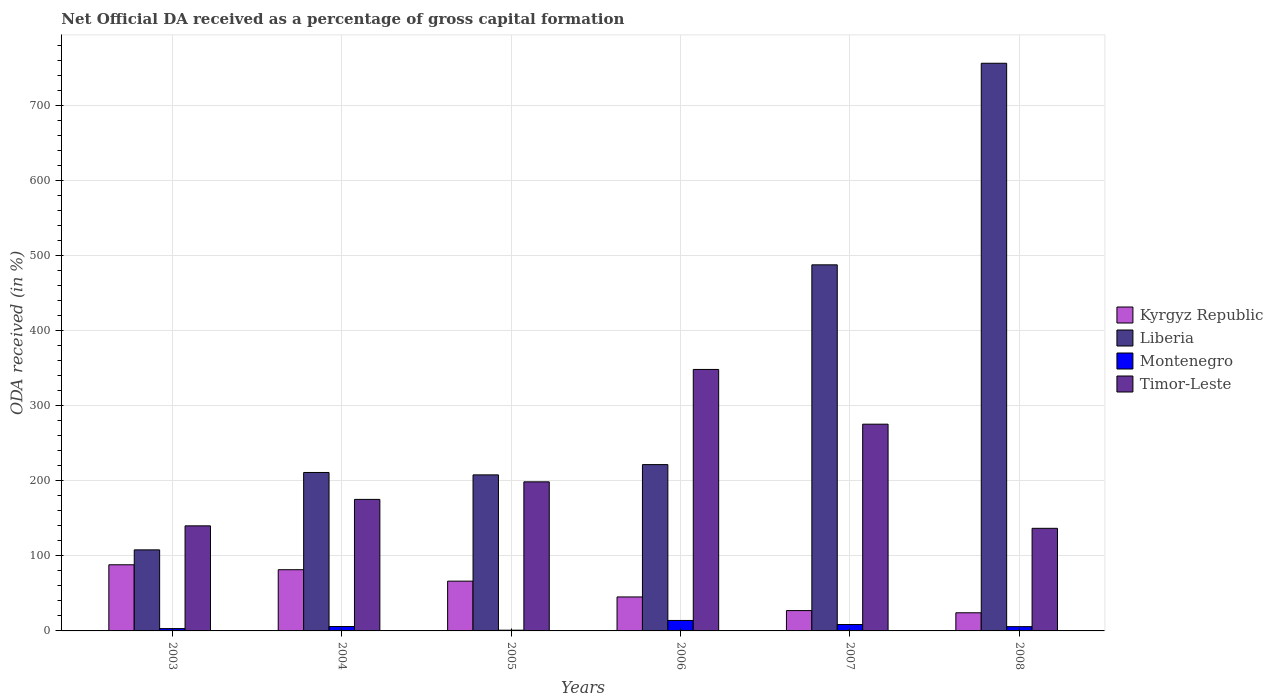How many different coloured bars are there?
Provide a succinct answer. 4. How many groups of bars are there?
Your answer should be compact. 6. Are the number of bars per tick equal to the number of legend labels?
Give a very brief answer. Yes. Are the number of bars on each tick of the X-axis equal?
Your answer should be compact. Yes. How many bars are there on the 4th tick from the left?
Keep it short and to the point. 4. How many bars are there on the 2nd tick from the right?
Your answer should be very brief. 4. In how many cases, is the number of bars for a given year not equal to the number of legend labels?
Provide a short and direct response. 0. What is the net ODA received in Timor-Leste in 2008?
Provide a succinct answer. 136.72. Across all years, what is the maximum net ODA received in Montenegro?
Keep it short and to the point. 13.93. Across all years, what is the minimum net ODA received in Timor-Leste?
Ensure brevity in your answer.  136.72. What is the total net ODA received in Montenegro in the graph?
Offer a terse response. 38.05. What is the difference between the net ODA received in Montenegro in 2004 and that in 2007?
Ensure brevity in your answer.  -2.68. What is the difference between the net ODA received in Timor-Leste in 2007 and the net ODA received in Montenegro in 2004?
Your answer should be very brief. 269.68. What is the average net ODA received in Timor-Leste per year?
Provide a short and direct response. 212.44. In the year 2008, what is the difference between the net ODA received in Montenegro and net ODA received in Liberia?
Offer a very short reply. -750.77. In how many years, is the net ODA received in Montenegro greater than 680 %?
Ensure brevity in your answer.  0. What is the ratio of the net ODA received in Timor-Leste in 2003 to that in 2005?
Your answer should be compact. 0.7. Is the difference between the net ODA received in Montenegro in 2003 and 2008 greater than the difference between the net ODA received in Liberia in 2003 and 2008?
Provide a short and direct response. Yes. What is the difference between the highest and the second highest net ODA received in Liberia?
Give a very brief answer. 268.63. What is the difference between the highest and the lowest net ODA received in Kyrgyz Republic?
Offer a very short reply. 63.95. In how many years, is the net ODA received in Kyrgyz Republic greater than the average net ODA received in Kyrgyz Republic taken over all years?
Your response must be concise. 3. Is it the case that in every year, the sum of the net ODA received in Liberia and net ODA received in Timor-Leste is greater than the sum of net ODA received in Kyrgyz Republic and net ODA received in Montenegro?
Ensure brevity in your answer.  No. What does the 1st bar from the left in 2008 represents?
Give a very brief answer. Kyrgyz Republic. What does the 1st bar from the right in 2007 represents?
Provide a short and direct response. Timor-Leste. Are all the bars in the graph horizontal?
Provide a succinct answer. No. How many years are there in the graph?
Ensure brevity in your answer.  6. What is the difference between two consecutive major ticks on the Y-axis?
Give a very brief answer. 100. Are the values on the major ticks of Y-axis written in scientific E-notation?
Your response must be concise. No. Does the graph contain any zero values?
Ensure brevity in your answer.  No. Does the graph contain grids?
Offer a very short reply. Yes. How are the legend labels stacked?
Your response must be concise. Vertical. What is the title of the graph?
Provide a short and direct response. Net Official DA received as a percentage of gross capital formation. Does "San Marino" appear as one of the legend labels in the graph?
Your answer should be compact. No. What is the label or title of the X-axis?
Keep it short and to the point. Years. What is the label or title of the Y-axis?
Ensure brevity in your answer.  ODA received (in %). What is the ODA received (in %) in Kyrgyz Republic in 2003?
Keep it short and to the point. 88.14. What is the ODA received (in %) of Liberia in 2003?
Offer a very short reply. 108.02. What is the ODA received (in %) in Montenegro in 2003?
Make the answer very short. 3.09. What is the ODA received (in %) in Timor-Leste in 2003?
Your response must be concise. 140.02. What is the ODA received (in %) in Kyrgyz Republic in 2004?
Ensure brevity in your answer.  81.57. What is the ODA received (in %) in Liberia in 2004?
Offer a terse response. 211.14. What is the ODA received (in %) in Montenegro in 2004?
Provide a short and direct response. 5.84. What is the ODA received (in %) in Timor-Leste in 2004?
Keep it short and to the point. 175.26. What is the ODA received (in %) in Kyrgyz Republic in 2005?
Offer a very short reply. 66.32. What is the ODA received (in %) in Liberia in 2005?
Give a very brief answer. 207.93. What is the ODA received (in %) in Montenegro in 2005?
Your response must be concise. 0.96. What is the ODA received (in %) in Timor-Leste in 2005?
Keep it short and to the point. 198.67. What is the ODA received (in %) in Kyrgyz Republic in 2006?
Offer a very short reply. 45.29. What is the ODA received (in %) in Liberia in 2006?
Your response must be concise. 221.64. What is the ODA received (in %) in Montenegro in 2006?
Your answer should be very brief. 13.93. What is the ODA received (in %) in Timor-Leste in 2006?
Make the answer very short. 348.45. What is the ODA received (in %) in Kyrgyz Republic in 2007?
Your response must be concise. 27.09. What is the ODA received (in %) of Liberia in 2007?
Ensure brevity in your answer.  487.84. What is the ODA received (in %) of Montenegro in 2007?
Ensure brevity in your answer.  8.52. What is the ODA received (in %) of Timor-Leste in 2007?
Your answer should be very brief. 275.51. What is the ODA received (in %) of Kyrgyz Republic in 2008?
Offer a terse response. 24.19. What is the ODA received (in %) in Liberia in 2008?
Your answer should be very brief. 756.47. What is the ODA received (in %) of Montenegro in 2008?
Provide a short and direct response. 5.7. What is the ODA received (in %) in Timor-Leste in 2008?
Give a very brief answer. 136.72. Across all years, what is the maximum ODA received (in %) of Kyrgyz Republic?
Your answer should be compact. 88.14. Across all years, what is the maximum ODA received (in %) of Liberia?
Offer a terse response. 756.47. Across all years, what is the maximum ODA received (in %) in Montenegro?
Ensure brevity in your answer.  13.93. Across all years, what is the maximum ODA received (in %) of Timor-Leste?
Provide a short and direct response. 348.45. Across all years, what is the minimum ODA received (in %) in Kyrgyz Republic?
Give a very brief answer. 24.19. Across all years, what is the minimum ODA received (in %) in Liberia?
Make the answer very short. 108.02. Across all years, what is the minimum ODA received (in %) of Montenegro?
Offer a very short reply. 0.96. Across all years, what is the minimum ODA received (in %) in Timor-Leste?
Provide a succinct answer. 136.72. What is the total ODA received (in %) in Kyrgyz Republic in the graph?
Offer a very short reply. 332.6. What is the total ODA received (in %) of Liberia in the graph?
Offer a very short reply. 1993.05. What is the total ODA received (in %) in Montenegro in the graph?
Keep it short and to the point. 38.05. What is the total ODA received (in %) of Timor-Leste in the graph?
Your answer should be very brief. 1274.64. What is the difference between the ODA received (in %) in Kyrgyz Republic in 2003 and that in 2004?
Your answer should be compact. 6.57. What is the difference between the ODA received (in %) of Liberia in 2003 and that in 2004?
Your response must be concise. -103.12. What is the difference between the ODA received (in %) of Montenegro in 2003 and that in 2004?
Provide a succinct answer. -2.75. What is the difference between the ODA received (in %) in Timor-Leste in 2003 and that in 2004?
Give a very brief answer. -35.24. What is the difference between the ODA received (in %) of Kyrgyz Republic in 2003 and that in 2005?
Offer a very short reply. 21.82. What is the difference between the ODA received (in %) of Liberia in 2003 and that in 2005?
Your response must be concise. -99.91. What is the difference between the ODA received (in %) in Montenegro in 2003 and that in 2005?
Your response must be concise. 2.13. What is the difference between the ODA received (in %) of Timor-Leste in 2003 and that in 2005?
Provide a succinct answer. -58.64. What is the difference between the ODA received (in %) of Kyrgyz Republic in 2003 and that in 2006?
Keep it short and to the point. 42.86. What is the difference between the ODA received (in %) in Liberia in 2003 and that in 2006?
Offer a very short reply. -113.62. What is the difference between the ODA received (in %) in Montenegro in 2003 and that in 2006?
Provide a succinct answer. -10.84. What is the difference between the ODA received (in %) in Timor-Leste in 2003 and that in 2006?
Your answer should be compact. -208.43. What is the difference between the ODA received (in %) in Kyrgyz Republic in 2003 and that in 2007?
Offer a very short reply. 61.05. What is the difference between the ODA received (in %) in Liberia in 2003 and that in 2007?
Your response must be concise. -379.82. What is the difference between the ODA received (in %) of Montenegro in 2003 and that in 2007?
Give a very brief answer. -5.43. What is the difference between the ODA received (in %) in Timor-Leste in 2003 and that in 2007?
Your answer should be compact. -135.49. What is the difference between the ODA received (in %) of Kyrgyz Republic in 2003 and that in 2008?
Provide a succinct answer. 63.95. What is the difference between the ODA received (in %) of Liberia in 2003 and that in 2008?
Keep it short and to the point. -648.45. What is the difference between the ODA received (in %) in Montenegro in 2003 and that in 2008?
Your response must be concise. -2.61. What is the difference between the ODA received (in %) of Timor-Leste in 2003 and that in 2008?
Provide a succinct answer. 3.3. What is the difference between the ODA received (in %) of Kyrgyz Republic in 2004 and that in 2005?
Keep it short and to the point. 15.25. What is the difference between the ODA received (in %) in Liberia in 2004 and that in 2005?
Give a very brief answer. 3.2. What is the difference between the ODA received (in %) in Montenegro in 2004 and that in 2005?
Make the answer very short. 4.87. What is the difference between the ODA received (in %) of Timor-Leste in 2004 and that in 2005?
Ensure brevity in your answer.  -23.41. What is the difference between the ODA received (in %) of Kyrgyz Republic in 2004 and that in 2006?
Provide a short and direct response. 36.29. What is the difference between the ODA received (in %) of Liberia in 2004 and that in 2006?
Your answer should be very brief. -10.5. What is the difference between the ODA received (in %) in Montenegro in 2004 and that in 2006?
Ensure brevity in your answer.  -8.1. What is the difference between the ODA received (in %) of Timor-Leste in 2004 and that in 2006?
Make the answer very short. -173.19. What is the difference between the ODA received (in %) of Kyrgyz Republic in 2004 and that in 2007?
Make the answer very short. 54.48. What is the difference between the ODA received (in %) of Liberia in 2004 and that in 2007?
Your response must be concise. -276.7. What is the difference between the ODA received (in %) of Montenegro in 2004 and that in 2007?
Offer a terse response. -2.68. What is the difference between the ODA received (in %) in Timor-Leste in 2004 and that in 2007?
Offer a terse response. -100.25. What is the difference between the ODA received (in %) in Kyrgyz Republic in 2004 and that in 2008?
Offer a terse response. 57.38. What is the difference between the ODA received (in %) of Liberia in 2004 and that in 2008?
Ensure brevity in your answer.  -545.33. What is the difference between the ODA received (in %) of Montenegro in 2004 and that in 2008?
Your response must be concise. 0.13. What is the difference between the ODA received (in %) of Timor-Leste in 2004 and that in 2008?
Your answer should be very brief. 38.54. What is the difference between the ODA received (in %) in Kyrgyz Republic in 2005 and that in 2006?
Offer a terse response. 21.03. What is the difference between the ODA received (in %) in Liberia in 2005 and that in 2006?
Make the answer very short. -13.7. What is the difference between the ODA received (in %) in Montenegro in 2005 and that in 2006?
Your answer should be very brief. -12.97. What is the difference between the ODA received (in %) of Timor-Leste in 2005 and that in 2006?
Ensure brevity in your answer.  -149.78. What is the difference between the ODA received (in %) of Kyrgyz Republic in 2005 and that in 2007?
Offer a terse response. 39.23. What is the difference between the ODA received (in %) of Liberia in 2005 and that in 2007?
Your response must be concise. -279.91. What is the difference between the ODA received (in %) of Montenegro in 2005 and that in 2007?
Offer a terse response. -7.55. What is the difference between the ODA received (in %) in Timor-Leste in 2005 and that in 2007?
Your answer should be compact. -76.85. What is the difference between the ODA received (in %) of Kyrgyz Republic in 2005 and that in 2008?
Offer a very short reply. 42.13. What is the difference between the ODA received (in %) in Liberia in 2005 and that in 2008?
Provide a succinct answer. -548.54. What is the difference between the ODA received (in %) of Montenegro in 2005 and that in 2008?
Offer a very short reply. -4.74. What is the difference between the ODA received (in %) in Timor-Leste in 2005 and that in 2008?
Offer a terse response. 61.95. What is the difference between the ODA received (in %) of Kyrgyz Republic in 2006 and that in 2007?
Keep it short and to the point. 18.2. What is the difference between the ODA received (in %) of Liberia in 2006 and that in 2007?
Your answer should be very brief. -266.2. What is the difference between the ODA received (in %) in Montenegro in 2006 and that in 2007?
Your answer should be compact. 5.42. What is the difference between the ODA received (in %) in Timor-Leste in 2006 and that in 2007?
Provide a succinct answer. 72.94. What is the difference between the ODA received (in %) in Kyrgyz Republic in 2006 and that in 2008?
Offer a very short reply. 21.1. What is the difference between the ODA received (in %) in Liberia in 2006 and that in 2008?
Provide a succinct answer. -534.83. What is the difference between the ODA received (in %) in Montenegro in 2006 and that in 2008?
Keep it short and to the point. 8.23. What is the difference between the ODA received (in %) of Timor-Leste in 2006 and that in 2008?
Your answer should be very brief. 211.73. What is the difference between the ODA received (in %) of Kyrgyz Republic in 2007 and that in 2008?
Your answer should be compact. 2.9. What is the difference between the ODA received (in %) in Liberia in 2007 and that in 2008?
Give a very brief answer. -268.63. What is the difference between the ODA received (in %) in Montenegro in 2007 and that in 2008?
Offer a very short reply. 2.81. What is the difference between the ODA received (in %) in Timor-Leste in 2007 and that in 2008?
Make the answer very short. 138.8. What is the difference between the ODA received (in %) of Kyrgyz Republic in 2003 and the ODA received (in %) of Liberia in 2004?
Your answer should be very brief. -123. What is the difference between the ODA received (in %) of Kyrgyz Republic in 2003 and the ODA received (in %) of Montenegro in 2004?
Your answer should be compact. 82.3. What is the difference between the ODA received (in %) of Kyrgyz Republic in 2003 and the ODA received (in %) of Timor-Leste in 2004?
Ensure brevity in your answer.  -87.12. What is the difference between the ODA received (in %) in Liberia in 2003 and the ODA received (in %) in Montenegro in 2004?
Make the answer very short. 102.18. What is the difference between the ODA received (in %) in Liberia in 2003 and the ODA received (in %) in Timor-Leste in 2004?
Offer a very short reply. -67.24. What is the difference between the ODA received (in %) in Montenegro in 2003 and the ODA received (in %) in Timor-Leste in 2004?
Offer a terse response. -172.17. What is the difference between the ODA received (in %) in Kyrgyz Republic in 2003 and the ODA received (in %) in Liberia in 2005?
Your answer should be compact. -119.79. What is the difference between the ODA received (in %) of Kyrgyz Republic in 2003 and the ODA received (in %) of Montenegro in 2005?
Keep it short and to the point. 87.18. What is the difference between the ODA received (in %) in Kyrgyz Republic in 2003 and the ODA received (in %) in Timor-Leste in 2005?
Your answer should be compact. -110.52. What is the difference between the ODA received (in %) in Liberia in 2003 and the ODA received (in %) in Montenegro in 2005?
Make the answer very short. 107.06. What is the difference between the ODA received (in %) of Liberia in 2003 and the ODA received (in %) of Timor-Leste in 2005?
Provide a short and direct response. -90.65. What is the difference between the ODA received (in %) in Montenegro in 2003 and the ODA received (in %) in Timor-Leste in 2005?
Offer a very short reply. -195.57. What is the difference between the ODA received (in %) of Kyrgyz Republic in 2003 and the ODA received (in %) of Liberia in 2006?
Provide a succinct answer. -133.5. What is the difference between the ODA received (in %) in Kyrgyz Republic in 2003 and the ODA received (in %) in Montenegro in 2006?
Your answer should be very brief. 74.21. What is the difference between the ODA received (in %) in Kyrgyz Republic in 2003 and the ODA received (in %) in Timor-Leste in 2006?
Provide a succinct answer. -260.31. What is the difference between the ODA received (in %) in Liberia in 2003 and the ODA received (in %) in Montenegro in 2006?
Offer a very short reply. 94.09. What is the difference between the ODA received (in %) in Liberia in 2003 and the ODA received (in %) in Timor-Leste in 2006?
Ensure brevity in your answer.  -240.43. What is the difference between the ODA received (in %) of Montenegro in 2003 and the ODA received (in %) of Timor-Leste in 2006?
Offer a terse response. -345.36. What is the difference between the ODA received (in %) of Kyrgyz Republic in 2003 and the ODA received (in %) of Liberia in 2007?
Your answer should be compact. -399.7. What is the difference between the ODA received (in %) in Kyrgyz Republic in 2003 and the ODA received (in %) in Montenegro in 2007?
Offer a terse response. 79.62. What is the difference between the ODA received (in %) of Kyrgyz Republic in 2003 and the ODA received (in %) of Timor-Leste in 2007?
Make the answer very short. -187.37. What is the difference between the ODA received (in %) in Liberia in 2003 and the ODA received (in %) in Montenegro in 2007?
Your answer should be very brief. 99.5. What is the difference between the ODA received (in %) in Liberia in 2003 and the ODA received (in %) in Timor-Leste in 2007?
Keep it short and to the point. -167.49. What is the difference between the ODA received (in %) of Montenegro in 2003 and the ODA received (in %) of Timor-Leste in 2007?
Ensure brevity in your answer.  -272.42. What is the difference between the ODA received (in %) of Kyrgyz Republic in 2003 and the ODA received (in %) of Liberia in 2008?
Give a very brief answer. -668.33. What is the difference between the ODA received (in %) of Kyrgyz Republic in 2003 and the ODA received (in %) of Montenegro in 2008?
Your answer should be compact. 82.44. What is the difference between the ODA received (in %) in Kyrgyz Republic in 2003 and the ODA received (in %) in Timor-Leste in 2008?
Your answer should be very brief. -48.58. What is the difference between the ODA received (in %) of Liberia in 2003 and the ODA received (in %) of Montenegro in 2008?
Your response must be concise. 102.32. What is the difference between the ODA received (in %) in Liberia in 2003 and the ODA received (in %) in Timor-Leste in 2008?
Ensure brevity in your answer.  -28.7. What is the difference between the ODA received (in %) in Montenegro in 2003 and the ODA received (in %) in Timor-Leste in 2008?
Your answer should be compact. -133.63. What is the difference between the ODA received (in %) of Kyrgyz Republic in 2004 and the ODA received (in %) of Liberia in 2005?
Provide a short and direct response. -126.36. What is the difference between the ODA received (in %) in Kyrgyz Republic in 2004 and the ODA received (in %) in Montenegro in 2005?
Give a very brief answer. 80.61. What is the difference between the ODA received (in %) of Kyrgyz Republic in 2004 and the ODA received (in %) of Timor-Leste in 2005?
Keep it short and to the point. -117.09. What is the difference between the ODA received (in %) of Liberia in 2004 and the ODA received (in %) of Montenegro in 2005?
Offer a terse response. 210.17. What is the difference between the ODA received (in %) of Liberia in 2004 and the ODA received (in %) of Timor-Leste in 2005?
Provide a short and direct response. 12.47. What is the difference between the ODA received (in %) of Montenegro in 2004 and the ODA received (in %) of Timor-Leste in 2005?
Provide a succinct answer. -192.83. What is the difference between the ODA received (in %) in Kyrgyz Republic in 2004 and the ODA received (in %) in Liberia in 2006?
Provide a succinct answer. -140.07. What is the difference between the ODA received (in %) of Kyrgyz Republic in 2004 and the ODA received (in %) of Montenegro in 2006?
Your answer should be compact. 67.64. What is the difference between the ODA received (in %) in Kyrgyz Republic in 2004 and the ODA received (in %) in Timor-Leste in 2006?
Ensure brevity in your answer.  -266.88. What is the difference between the ODA received (in %) of Liberia in 2004 and the ODA received (in %) of Montenegro in 2006?
Provide a succinct answer. 197.2. What is the difference between the ODA received (in %) of Liberia in 2004 and the ODA received (in %) of Timor-Leste in 2006?
Make the answer very short. -137.31. What is the difference between the ODA received (in %) in Montenegro in 2004 and the ODA received (in %) in Timor-Leste in 2006?
Your answer should be compact. -342.61. What is the difference between the ODA received (in %) in Kyrgyz Republic in 2004 and the ODA received (in %) in Liberia in 2007?
Keep it short and to the point. -406.27. What is the difference between the ODA received (in %) in Kyrgyz Republic in 2004 and the ODA received (in %) in Montenegro in 2007?
Make the answer very short. 73.05. What is the difference between the ODA received (in %) in Kyrgyz Republic in 2004 and the ODA received (in %) in Timor-Leste in 2007?
Provide a short and direct response. -193.94. What is the difference between the ODA received (in %) of Liberia in 2004 and the ODA received (in %) of Montenegro in 2007?
Provide a succinct answer. 202.62. What is the difference between the ODA received (in %) of Liberia in 2004 and the ODA received (in %) of Timor-Leste in 2007?
Your answer should be compact. -64.38. What is the difference between the ODA received (in %) in Montenegro in 2004 and the ODA received (in %) in Timor-Leste in 2007?
Ensure brevity in your answer.  -269.68. What is the difference between the ODA received (in %) of Kyrgyz Republic in 2004 and the ODA received (in %) of Liberia in 2008?
Ensure brevity in your answer.  -674.9. What is the difference between the ODA received (in %) of Kyrgyz Republic in 2004 and the ODA received (in %) of Montenegro in 2008?
Give a very brief answer. 75.87. What is the difference between the ODA received (in %) in Kyrgyz Republic in 2004 and the ODA received (in %) in Timor-Leste in 2008?
Your answer should be compact. -55.15. What is the difference between the ODA received (in %) of Liberia in 2004 and the ODA received (in %) of Montenegro in 2008?
Keep it short and to the point. 205.43. What is the difference between the ODA received (in %) of Liberia in 2004 and the ODA received (in %) of Timor-Leste in 2008?
Your response must be concise. 74.42. What is the difference between the ODA received (in %) in Montenegro in 2004 and the ODA received (in %) in Timor-Leste in 2008?
Ensure brevity in your answer.  -130.88. What is the difference between the ODA received (in %) of Kyrgyz Republic in 2005 and the ODA received (in %) of Liberia in 2006?
Make the answer very short. -155.32. What is the difference between the ODA received (in %) in Kyrgyz Republic in 2005 and the ODA received (in %) in Montenegro in 2006?
Provide a short and direct response. 52.38. What is the difference between the ODA received (in %) of Kyrgyz Republic in 2005 and the ODA received (in %) of Timor-Leste in 2006?
Make the answer very short. -282.13. What is the difference between the ODA received (in %) of Liberia in 2005 and the ODA received (in %) of Montenegro in 2006?
Offer a very short reply. 194. What is the difference between the ODA received (in %) in Liberia in 2005 and the ODA received (in %) in Timor-Leste in 2006?
Keep it short and to the point. -140.52. What is the difference between the ODA received (in %) in Montenegro in 2005 and the ODA received (in %) in Timor-Leste in 2006?
Provide a succinct answer. -347.49. What is the difference between the ODA received (in %) of Kyrgyz Republic in 2005 and the ODA received (in %) of Liberia in 2007?
Give a very brief answer. -421.52. What is the difference between the ODA received (in %) of Kyrgyz Republic in 2005 and the ODA received (in %) of Montenegro in 2007?
Provide a succinct answer. 57.8. What is the difference between the ODA received (in %) in Kyrgyz Republic in 2005 and the ODA received (in %) in Timor-Leste in 2007?
Provide a succinct answer. -209.2. What is the difference between the ODA received (in %) in Liberia in 2005 and the ODA received (in %) in Montenegro in 2007?
Offer a very short reply. 199.42. What is the difference between the ODA received (in %) of Liberia in 2005 and the ODA received (in %) of Timor-Leste in 2007?
Give a very brief answer. -67.58. What is the difference between the ODA received (in %) in Montenegro in 2005 and the ODA received (in %) in Timor-Leste in 2007?
Give a very brief answer. -274.55. What is the difference between the ODA received (in %) in Kyrgyz Republic in 2005 and the ODA received (in %) in Liberia in 2008?
Offer a terse response. -690.15. What is the difference between the ODA received (in %) of Kyrgyz Republic in 2005 and the ODA received (in %) of Montenegro in 2008?
Offer a terse response. 60.61. What is the difference between the ODA received (in %) of Kyrgyz Republic in 2005 and the ODA received (in %) of Timor-Leste in 2008?
Keep it short and to the point. -70.4. What is the difference between the ODA received (in %) of Liberia in 2005 and the ODA received (in %) of Montenegro in 2008?
Your response must be concise. 202.23. What is the difference between the ODA received (in %) of Liberia in 2005 and the ODA received (in %) of Timor-Leste in 2008?
Keep it short and to the point. 71.22. What is the difference between the ODA received (in %) in Montenegro in 2005 and the ODA received (in %) in Timor-Leste in 2008?
Your response must be concise. -135.75. What is the difference between the ODA received (in %) of Kyrgyz Republic in 2006 and the ODA received (in %) of Liberia in 2007?
Keep it short and to the point. -442.55. What is the difference between the ODA received (in %) of Kyrgyz Republic in 2006 and the ODA received (in %) of Montenegro in 2007?
Offer a terse response. 36.77. What is the difference between the ODA received (in %) in Kyrgyz Republic in 2006 and the ODA received (in %) in Timor-Leste in 2007?
Provide a succinct answer. -230.23. What is the difference between the ODA received (in %) in Liberia in 2006 and the ODA received (in %) in Montenegro in 2007?
Provide a succinct answer. 213.12. What is the difference between the ODA received (in %) of Liberia in 2006 and the ODA received (in %) of Timor-Leste in 2007?
Your answer should be compact. -53.88. What is the difference between the ODA received (in %) in Montenegro in 2006 and the ODA received (in %) in Timor-Leste in 2007?
Offer a very short reply. -261.58. What is the difference between the ODA received (in %) in Kyrgyz Republic in 2006 and the ODA received (in %) in Liberia in 2008?
Provide a short and direct response. -711.19. What is the difference between the ODA received (in %) in Kyrgyz Republic in 2006 and the ODA received (in %) in Montenegro in 2008?
Provide a succinct answer. 39.58. What is the difference between the ODA received (in %) in Kyrgyz Republic in 2006 and the ODA received (in %) in Timor-Leste in 2008?
Offer a very short reply. -91.43. What is the difference between the ODA received (in %) in Liberia in 2006 and the ODA received (in %) in Montenegro in 2008?
Ensure brevity in your answer.  215.93. What is the difference between the ODA received (in %) of Liberia in 2006 and the ODA received (in %) of Timor-Leste in 2008?
Ensure brevity in your answer.  84.92. What is the difference between the ODA received (in %) in Montenegro in 2006 and the ODA received (in %) in Timor-Leste in 2008?
Provide a succinct answer. -122.78. What is the difference between the ODA received (in %) of Kyrgyz Republic in 2007 and the ODA received (in %) of Liberia in 2008?
Provide a short and direct response. -729.38. What is the difference between the ODA received (in %) of Kyrgyz Republic in 2007 and the ODA received (in %) of Montenegro in 2008?
Give a very brief answer. 21.39. What is the difference between the ODA received (in %) in Kyrgyz Republic in 2007 and the ODA received (in %) in Timor-Leste in 2008?
Make the answer very short. -109.63. What is the difference between the ODA received (in %) in Liberia in 2007 and the ODA received (in %) in Montenegro in 2008?
Your answer should be compact. 482.14. What is the difference between the ODA received (in %) of Liberia in 2007 and the ODA received (in %) of Timor-Leste in 2008?
Offer a terse response. 351.12. What is the difference between the ODA received (in %) of Montenegro in 2007 and the ODA received (in %) of Timor-Leste in 2008?
Provide a succinct answer. -128.2. What is the average ODA received (in %) of Kyrgyz Republic per year?
Keep it short and to the point. 55.43. What is the average ODA received (in %) of Liberia per year?
Your answer should be very brief. 332.17. What is the average ODA received (in %) in Montenegro per year?
Provide a short and direct response. 6.34. What is the average ODA received (in %) of Timor-Leste per year?
Keep it short and to the point. 212.44. In the year 2003, what is the difference between the ODA received (in %) in Kyrgyz Republic and ODA received (in %) in Liberia?
Keep it short and to the point. -19.88. In the year 2003, what is the difference between the ODA received (in %) in Kyrgyz Republic and ODA received (in %) in Montenegro?
Offer a very short reply. 85.05. In the year 2003, what is the difference between the ODA received (in %) in Kyrgyz Republic and ODA received (in %) in Timor-Leste?
Offer a terse response. -51.88. In the year 2003, what is the difference between the ODA received (in %) of Liberia and ODA received (in %) of Montenegro?
Offer a terse response. 104.93. In the year 2003, what is the difference between the ODA received (in %) of Liberia and ODA received (in %) of Timor-Leste?
Offer a very short reply. -32. In the year 2003, what is the difference between the ODA received (in %) of Montenegro and ODA received (in %) of Timor-Leste?
Provide a succinct answer. -136.93. In the year 2004, what is the difference between the ODA received (in %) of Kyrgyz Republic and ODA received (in %) of Liberia?
Give a very brief answer. -129.57. In the year 2004, what is the difference between the ODA received (in %) in Kyrgyz Republic and ODA received (in %) in Montenegro?
Ensure brevity in your answer.  75.73. In the year 2004, what is the difference between the ODA received (in %) of Kyrgyz Republic and ODA received (in %) of Timor-Leste?
Provide a succinct answer. -93.69. In the year 2004, what is the difference between the ODA received (in %) in Liberia and ODA received (in %) in Montenegro?
Your response must be concise. 205.3. In the year 2004, what is the difference between the ODA received (in %) in Liberia and ODA received (in %) in Timor-Leste?
Offer a terse response. 35.88. In the year 2004, what is the difference between the ODA received (in %) in Montenegro and ODA received (in %) in Timor-Leste?
Provide a short and direct response. -169.42. In the year 2005, what is the difference between the ODA received (in %) of Kyrgyz Republic and ODA received (in %) of Liberia?
Ensure brevity in your answer.  -141.62. In the year 2005, what is the difference between the ODA received (in %) of Kyrgyz Republic and ODA received (in %) of Montenegro?
Offer a terse response. 65.35. In the year 2005, what is the difference between the ODA received (in %) of Kyrgyz Republic and ODA received (in %) of Timor-Leste?
Provide a succinct answer. -132.35. In the year 2005, what is the difference between the ODA received (in %) of Liberia and ODA received (in %) of Montenegro?
Your answer should be compact. 206.97. In the year 2005, what is the difference between the ODA received (in %) of Liberia and ODA received (in %) of Timor-Leste?
Keep it short and to the point. 9.27. In the year 2005, what is the difference between the ODA received (in %) of Montenegro and ODA received (in %) of Timor-Leste?
Your response must be concise. -197.7. In the year 2006, what is the difference between the ODA received (in %) of Kyrgyz Republic and ODA received (in %) of Liberia?
Give a very brief answer. -176.35. In the year 2006, what is the difference between the ODA received (in %) in Kyrgyz Republic and ODA received (in %) in Montenegro?
Ensure brevity in your answer.  31.35. In the year 2006, what is the difference between the ODA received (in %) of Kyrgyz Republic and ODA received (in %) of Timor-Leste?
Offer a terse response. -303.16. In the year 2006, what is the difference between the ODA received (in %) in Liberia and ODA received (in %) in Montenegro?
Ensure brevity in your answer.  207.7. In the year 2006, what is the difference between the ODA received (in %) in Liberia and ODA received (in %) in Timor-Leste?
Offer a terse response. -126.81. In the year 2006, what is the difference between the ODA received (in %) of Montenegro and ODA received (in %) of Timor-Leste?
Offer a very short reply. -334.52. In the year 2007, what is the difference between the ODA received (in %) of Kyrgyz Republic and ODA received (in %) of Liberia?
Keep it short and to the point. -460.75. In the year 2007, what is the difference between the ODA received (in %) in Kyrgyz Republic and ODA received (in %) in Montenegro?
Your answer should be very brief. 18.57. In the year 2007, what is the difference between the ODA received (in %) of Kyrgyz Republic and ODA received (in %) of Timor-Leste?
Keep it short and to the point. -248.43. In the year 2007, what is the difference between the ODA received (in %) in Liberia and ODA received (in %) in Montenegro?
Offer a terse response. 479.32. In the year 2007, what is the difference between the ODA received (in %) in Liberia and ODA received (in %) in Timor-Leste?
Your answer should be compact. 212.33. In the year 2007, what is the difference between the ODA received (in %) in Montenegro and ODA received (in %) in Timor-Leste?
Offer a terse response. -267. In the year 2008, what is the difference between the ODA received (in %) of Kyrgyz Republic and ODA received (in %) of Liberia?
Keep it short and to the point. -732.28. In the year 2008, what is the difference between the ODA received (in %) of Kyrgyz Republic and ODA received (in %) of Montenegro?
Your response must be concise. 18.49. In the year 2008, what is the difference between the ODA received (in %) of Kyrgyz Republic and ODA received (in %) of Timor-Leste?
Your answer should be compact. -112.53. In the year 2008, what is the difference between the ODA received (in %) of Liberia and ODA received (in %) of Montenegro?
Make the answer very short. 750.77. In the year 2008, what is the difference between the ODA received (in %) in Liberia and ODA received (in %) in Timor-Leste?
Keep it short and to the point. 619.75. In the year 2008, what is the difference between the ODA received (in %) of Montenegro and ODA received (in %) of Timor-Leste?
Ensure brevity in your answer.  -131.01. What is the ratio of the ODA received (in %) in Kyrgyz Republic in 2003 to that in 2004?
Your answer should be compact. 1.08. What is the ratio of the ODA received (in %) in Liberia in 2003 to that in 2004?
Your answer should be very brief. 0.51. What is the ratio of the ODA received (in %) in Montenegro in 2003 to that in 2004?
Your answer should be very brief. 0.53. What is the ratio of the ODA received (in %) in Timor-Leste in 2003 to that in 2004?
Provide a short and direct response. 0.8. What is the ratio of the ODA received (in %) of Kyrgyz Republic in 2003 to that in 2005?
Offer a terse response. 1.33. What is the ratio of the ODA received (in %) of Liberia in 2003 to that in 2005?
Ensure brevity in your answer.  0.52. What is the ratio of the ODA received (in %) of Montenegro in 2003 to that in 2005?
Provide a succinct answer. 3.21. What is the ratio of the ODA received (in %) of Timor-Leste in 2003 to that in 2005?
Keep it short and to the point. 0.7. What is the ratio of the ODA received (in %) of Kyrgyz Republic in 2003 to that in 2006?
Keep it short and to the point. 1.95. What is the ratio of the ODA received (in %) in Liberia in 2003 to that in 2006?
Keep it short and to the point. 0.49. What is the ratio of the ODA received (in %) of Montenegro in 2003 to that in 2006?
Provide a short and direct response. 0.22. What is the ratio of the ODA received (in %) in Timor-Leste in 2003 to that in 2006?
Offer a terse response. 0.4. What is the ratio of the ODA received (in %) in Kyrgyz Republic in 2003 to that in 2007?
Ensure brevity in your answer.  3.25. What is the ratio of the ODA received (in %) in Liberia in 2003 to that in 2007?
Give a very brief answer. 0.22. What is the ratio of the ODA received (in %) in Montenegro in 2003 to that in 2007?
Offer a terse response. 0.36. What is the ratio of the ODA received (in %) in Timor-Leste in 2003 to that in 2007?
Your response must be concise. 0.51. What is the ratio of the ODA received (in %) of Kyrgyz Republic in 2003 to that in 2008?
Give a very brief answer. 3.64. What is the ratio of the ODA received (in %) in Liberia in 2003 to that in 2008?
Give a very brief answer. 0.14. What is the ratio of the ODA received (in %) of Montenegro in 2003 to that in 2008?
Ensure brevity in your answer.  0.54. What is the ratio of the ODA received (in %) in Timor-Leste in 2003 to that in 2008?
Keep it short and to the point. 1.02. What is the ratio of the ODA received (in %) of Kyrgyz Republic in 2004 to that in 2005?
Your response must be concise. 1.23. What is the ratio of the ODA received (in %) in Liberia in 2004 to that in 2005?
Ensure brevity in your answer.  1.02. What is the ratio of the ODA received (in %) of Montenegro in 2004 to that in 2005?
Your answer should be compact. 6.05. What is the ratio of the ODA received (in %) in Timor-Leste in 2004 to that in 2005?
Give a very brief answer. 0.88. What is the ratio of the ODA received (in %) in Kyrgyz Republic in 2004 to that in 2006?
Your response must be concise. 1.8. What is the ratio of the ODA received (in %) of Liberia in 2004 to that in 2006?
Your answer should be very brief. 0.95. What is the ratio of the ODA received (in %) in Montenegro in 2004 to that in 2006?
Your answer should be compact. 0.42. What is the ratio of the ODA received (in %) of Timor-Leste in 2004 to that in 2006?
Offer a very short reply. 0.5. What is the ratio of the ODA received (in %) in Kyrgyz Republic in 2004 to that in 2007?
Your answer should be very brief. 3.01. What is the ratio of the ODA received (in %) of Liberia in 2004 to that in 2007?
Provide a short and direct response. 0.43. What is the ratio of the ODA received (in %) in Montenegro in 2004 to that in 2007?
Give a very brief answer. 0.69. What is the ratio of the ODA received (in %) in Timor-Leste in 2004 to that in 2007?
Offer a terse response. 0.64. What is the ratio of the ODA received (in %) of Kyrgyz Republic in 2004 to that in 2008?
Give a very brief answer. 3.37. What is the ratio of the ODA received (in %) of Liberia in 2004 to that in 2008?
Offer a very short reply. 0.28. What is the ratio of the ODA received (in %) in Montenegro in 2004 to that in 2008?
Give a very brief answer. 1.02. What is the ratio of the ODA received (in %) of Timor-Leste in 2004 to that in 2008?
Your response must be concise. 1.28. What is the ratio of the ODA received (in %) of Kyrgyz Republic in 2005 to that in 2006?
Your response must be concise. 1.46. What is the ratio of the ODA received (in %) of Liberia in 2005 to that in 2006?
Your response must be concise. 0.94. What is the ratio of the ODA received (in %) in Montenegro in 2005 to that in 2006?
Provide a succinct answer. 0.07. What is the ratio of the ODA received (in %) in Timor-Leste in 2005 to that in 2006?
Offer a very short reply. 0.57. What is the ratio of the ODA received (in %) of Kyrgyz Republic in 2005 to that in 2007?
Your answer should be very brief. 2.45. What is the ratio of the ODA received (in %) in Liberia in 2005 to that in 2007?
Your answer should be very brief. 0.43. What is the ratio of the ODA received (in %) in Montenegro in 2005 to that in 2007?
Your answer should be very brief. 0.11. What is the ratio of the ODA received (in %) in Timor-Leste in 2005 to that in 2007?
Your answer should be compact. 0.72. What is the ratio of the ODA received (in %) of Kyrgyz Republic in 2005 to that in 2008?
Provide a succinct answer. 2.74. What is the ratio of the ODA received (in %) in Liberia in 2005 to that in 2008?
Provide a succinct answer. 0.27. What is the ratio of the ODA received (in %) of Montenegro in 2005 to that in 2008?
Your answer should be compact. 0.17. What is the ratio of the ODA received (in %) of Timor-Leste in 2005 to that in 2008?
Your response must be concise. 1.45. What is the ratio of the ODA received (in %) in Kyrgyz Republic in 2006 to that in 2007?
Provide a succinct answer. 1.67. What is the ratio of the ODA received (in %) in Liberia in 2006 to that in 2007?
Keep it short and to the point. 0.45. What is the ratio of the ODA received (in %) of Montenegro in 2006 to that in 2007?
Provide a succinct answer. 1.64. What is the ratio of the ODA received (in %) of Timor-Leste in 2006 to that in 2007?
Your response must be concise. 1.26. What is the ratio of the ODA received (in %) in Kyrgyz Republic in 2006 to that in 2008?
Provide a succinct answer. 1.87. What is the ratio of the ODA received (in %) of Liberia in 2006 to that in 2008?
Make the answer very short. 0.29. What is the ratio of the ODA received (in %) of Montenegro in 2006 to that in 2008?
Give a very brief answer. 2.44. What is the ratio of the ODA received (in %) of Timor-Leste in 2006 to that in 2008?
Ensure brevity in your answer.  2.55. What is the ratio of the ODA received (in %) in Kyrgyz Republic in 2007 to that in 2008?
Your answer should be compact. 1.12. What is the ratio of the ODA received (in %) in Liberia in 2007 to that in 2008?
Keep it short and to the point. 0.64. What is the ratio of the ODA received (in %) of Montenegro in 2007 to that in 2008?
Ensure brevity in your answer.  1.49. What is the ratio of the ODA received (in %) in Timor-Leste in 2007 to that in 2008?
Provide a succinct answer. 2.02. What is the difference between the highest and the second highest ODA received (in %) of Kyrgyz Republic?
Your answer should be compact. 6.57. What is the difference between the highest and the second highest ODA received (in %) of Liberia?
Offer a terse response. 268.63. What is the difference between the highest and the second highest ODA received (in %) in Montenegro?
Give a very brief answer. 5.42. What is the difference between the highest and the second highest ODA received (in %) of Timor-Leste?
Ensure brevity in your answer.  72.94. What is the difference between the highest and the lowest ODA received (in %) of Kyrgyz Republic?
Offer a terse response. 63.95. What is the difference between the highest and the lowest ODA received (in %) in Liberia?
Ensure brevity in your answer.  648.45. What is the difference between the highest and the lowest ODA received (in %) in Montenegro?
Provide a short and direct response. 12.97. What is the difference between the highest and the lowest ODA received (in %) of Timor-Leste?
Provide a succinct answer. 211.73. 